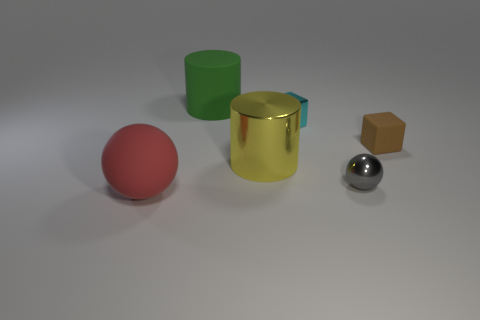There is a sphere behind the red rubber sphere; is it the same color as the cylinder that is behind the tiny cyan metallic thing? no 